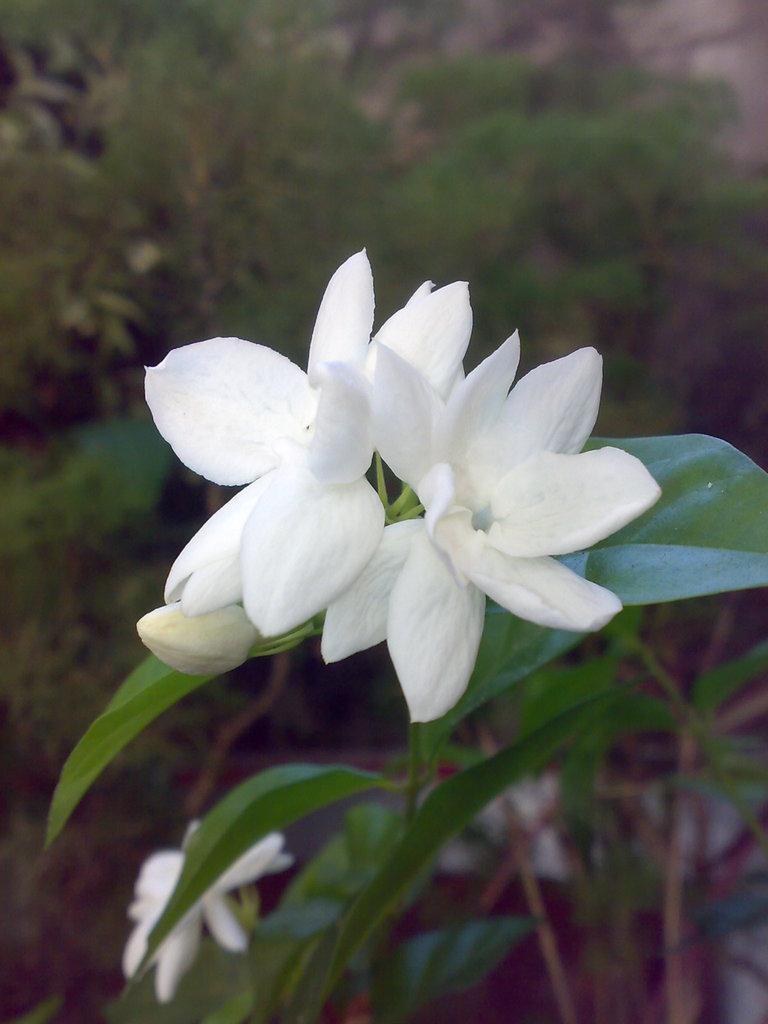In one or two sentences, can you explain what this image depicts? This is a zoomed in picture. In the center we can see the plants and the white color flowers. In the background we can see the grass and the plants. 